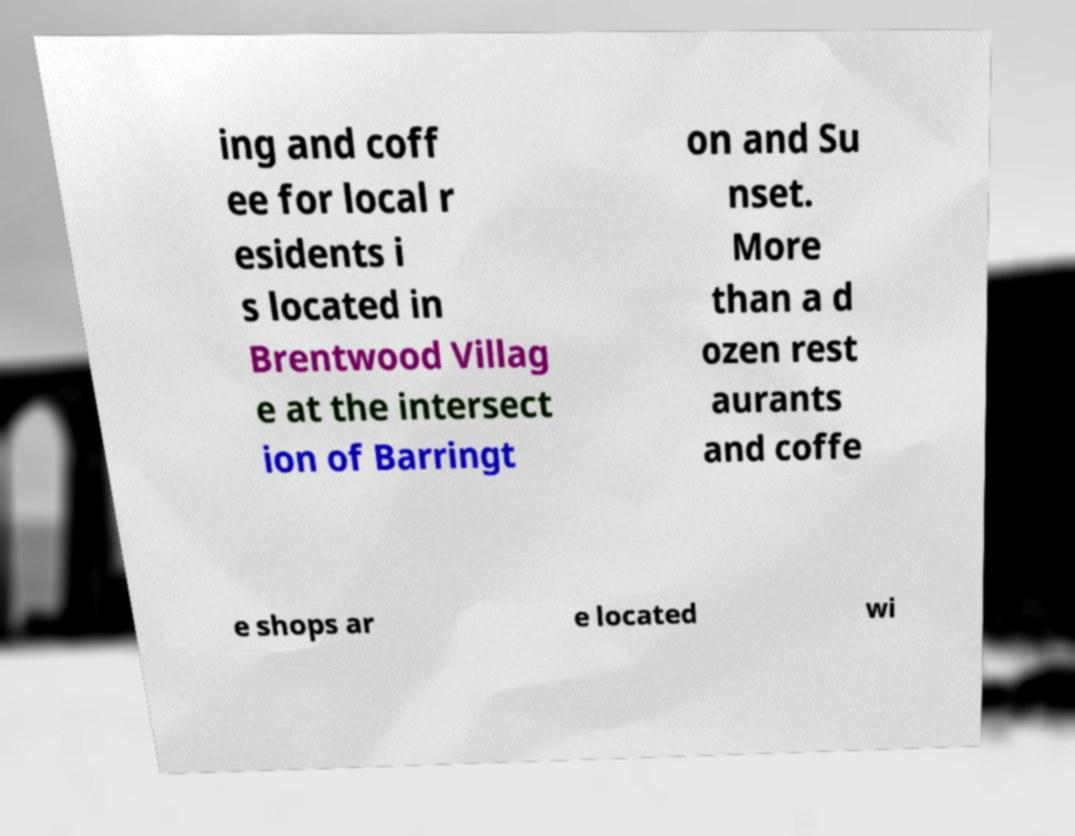For documentation purposes, I need the text within this image transcribed. Could you provide that? ing and coff ee for local r esidents i s located in Brentwood Villag e at the intersect ion of Barringt on and Su nset. More than a d ozen rest aurants and coffe e shops ar e located wi 